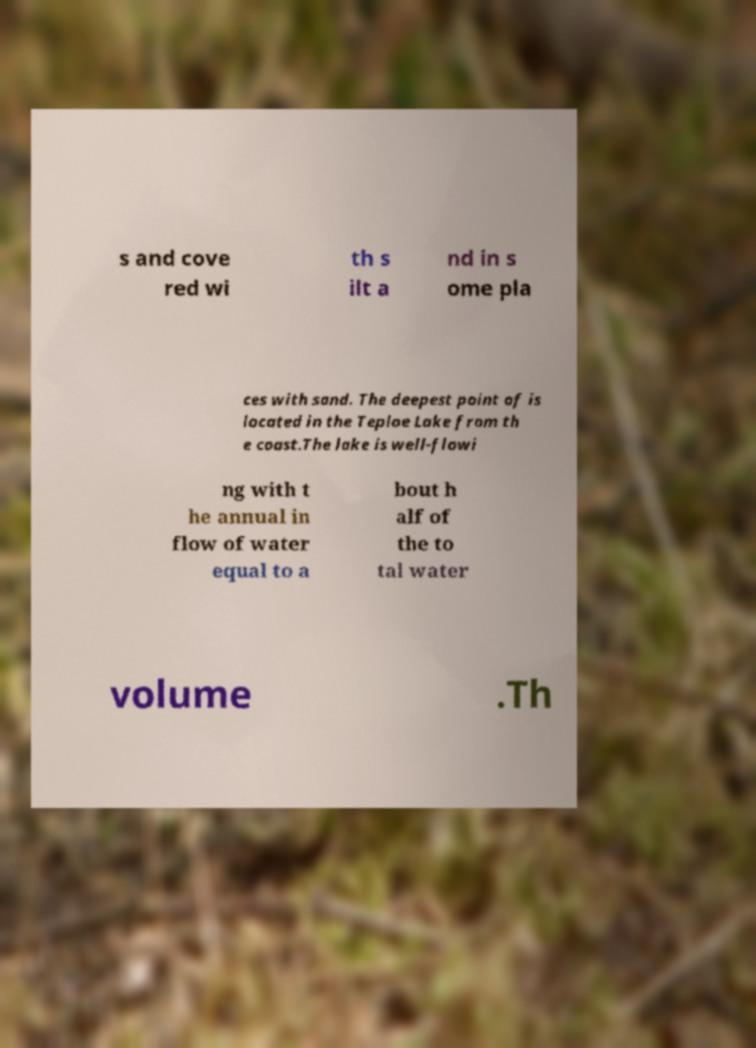Could you assist in decoding the text presented in this image and type it out clearly? s and cove red wi th s ilt a nd in s ome pla ces with sand. The deepest point of is located in the Teploe Lake from th e coast.The lake is well-flowi ng with t he annual in flow of water equal to a bout h alf of the to tal water volume .Th 